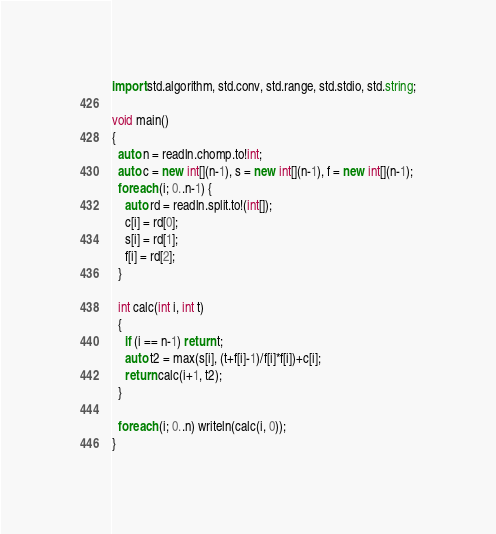Convert code to text. <code><loc_0><loc_0><loc_500><loc_500><_D_>import std.algorithm, std.conv, std.range, std.stdio, std.string;

void main()
{
  auto n = readln.chomp.to!int;
  auto c = new int[](n-1), s = new int[](n-1), f = new int[](n-1);
  foreach (i; 0..n-1) {
    auto rd = readln.split.to!(int[]);
    c[i] = rd[0];
    s[i] = rd[1];
    f[i] = rd[2];
  }

  int calc(int i, int t)
  {
    if (i == n-1) return t;
    auto t2 = max(s[i], (t+f[i]-1)/f[i]*f[i])+c[i];
    return calc(i+1, t2);
  }

  foreach (i; 0..n) writeln(calc(i, 0));
}
</code> 